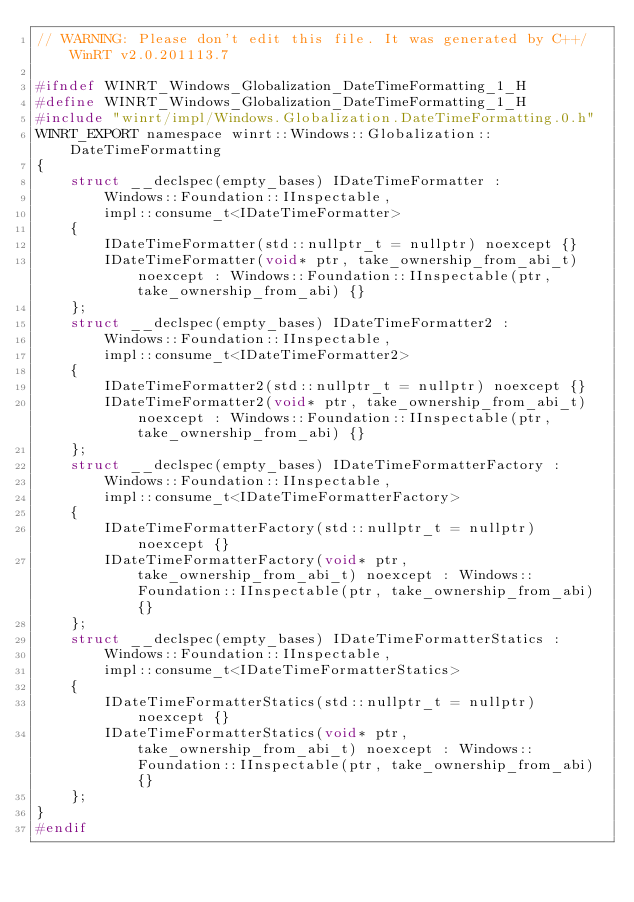<code> <loc_0><loc_0><loc_500><loc_500><_C_>// WARNING: Please don't edit this file. It was generated by C++/WinRT v2.0.201113.7

#ifndef WINRT_Windows_Globalization_DateTimeFormatting_1_H
#define WINRT_Windows_Globalization_DateTimeFormatting_1_H
#include "winrt/impl/Windows.Globalization.DateTimeFormatting.0.h"
WINRT_EXPORT namespace winrt::Windows::Globalization::DateTimeFormatting
{
    struct __declspec(empty_bases) IDateTimeFormatter :
        Windows::Foundation::IInspectable,
        impl::consume_t<IDateTimeFormatter>
    {
        IDateTimeFormatter(std::nullptr_t = nullptr) noexcept {}
        IDateTimeFormatter(void* ptr, take_ownership_from_abi_t) noexcept : Windows::Foundation::IInspectable(ptr, take_ownership_from_abi) {}
    };
    struct __declspec(empty_bases) IDateTimeFormatter2 :
        Windows::Foundation::IInspectable,
        impl::consume_t<IDateTimeFormatter2>
    {
        IDateTimeFormatter2(std::nullptr_t = nullptr) noexcept {}
        IDateTimeFormatter2(void* ptr, take_ownership_from_abi_t) noexcept : Windows::Foundation::IInspectable(ptr, take_ownership_from_abi) {}
    };
    struct __declspec(empty_bases) IDateTimeFormatterFactory :
        Windows::Foundation::IInspectable,
        impl::consume_t<IDateTimeFormatterFactory>
    {
        IDateTimeFormatterFactory(std::nullptr_t = nullptr) noexcept {}
        IDateTimeFormatterFactory(void* ptr, take_ownership_from_abi_t) noexcept : Windows::Foundation::IInspectable(ptr, take_ownership_from_abi) {}
    };
    struct __declspec(empty_bases) IDateTimeFormatterStatics :
        Windows::Foundation::IInspectable,
        impl::consume_t<IDateTimeFormatterStatics>
    {
        IDateTimeFormatterStatics(std::nullptr_t = nullptr) noexcept {}
        IDateTimeFormatterStatics(void* ptr, take_ownership_from_abi_t) noexcept : Windows::Foundation::IInspectable(ptr, take_ownership_from_abi) {}
    };
}
#endif
</code> 